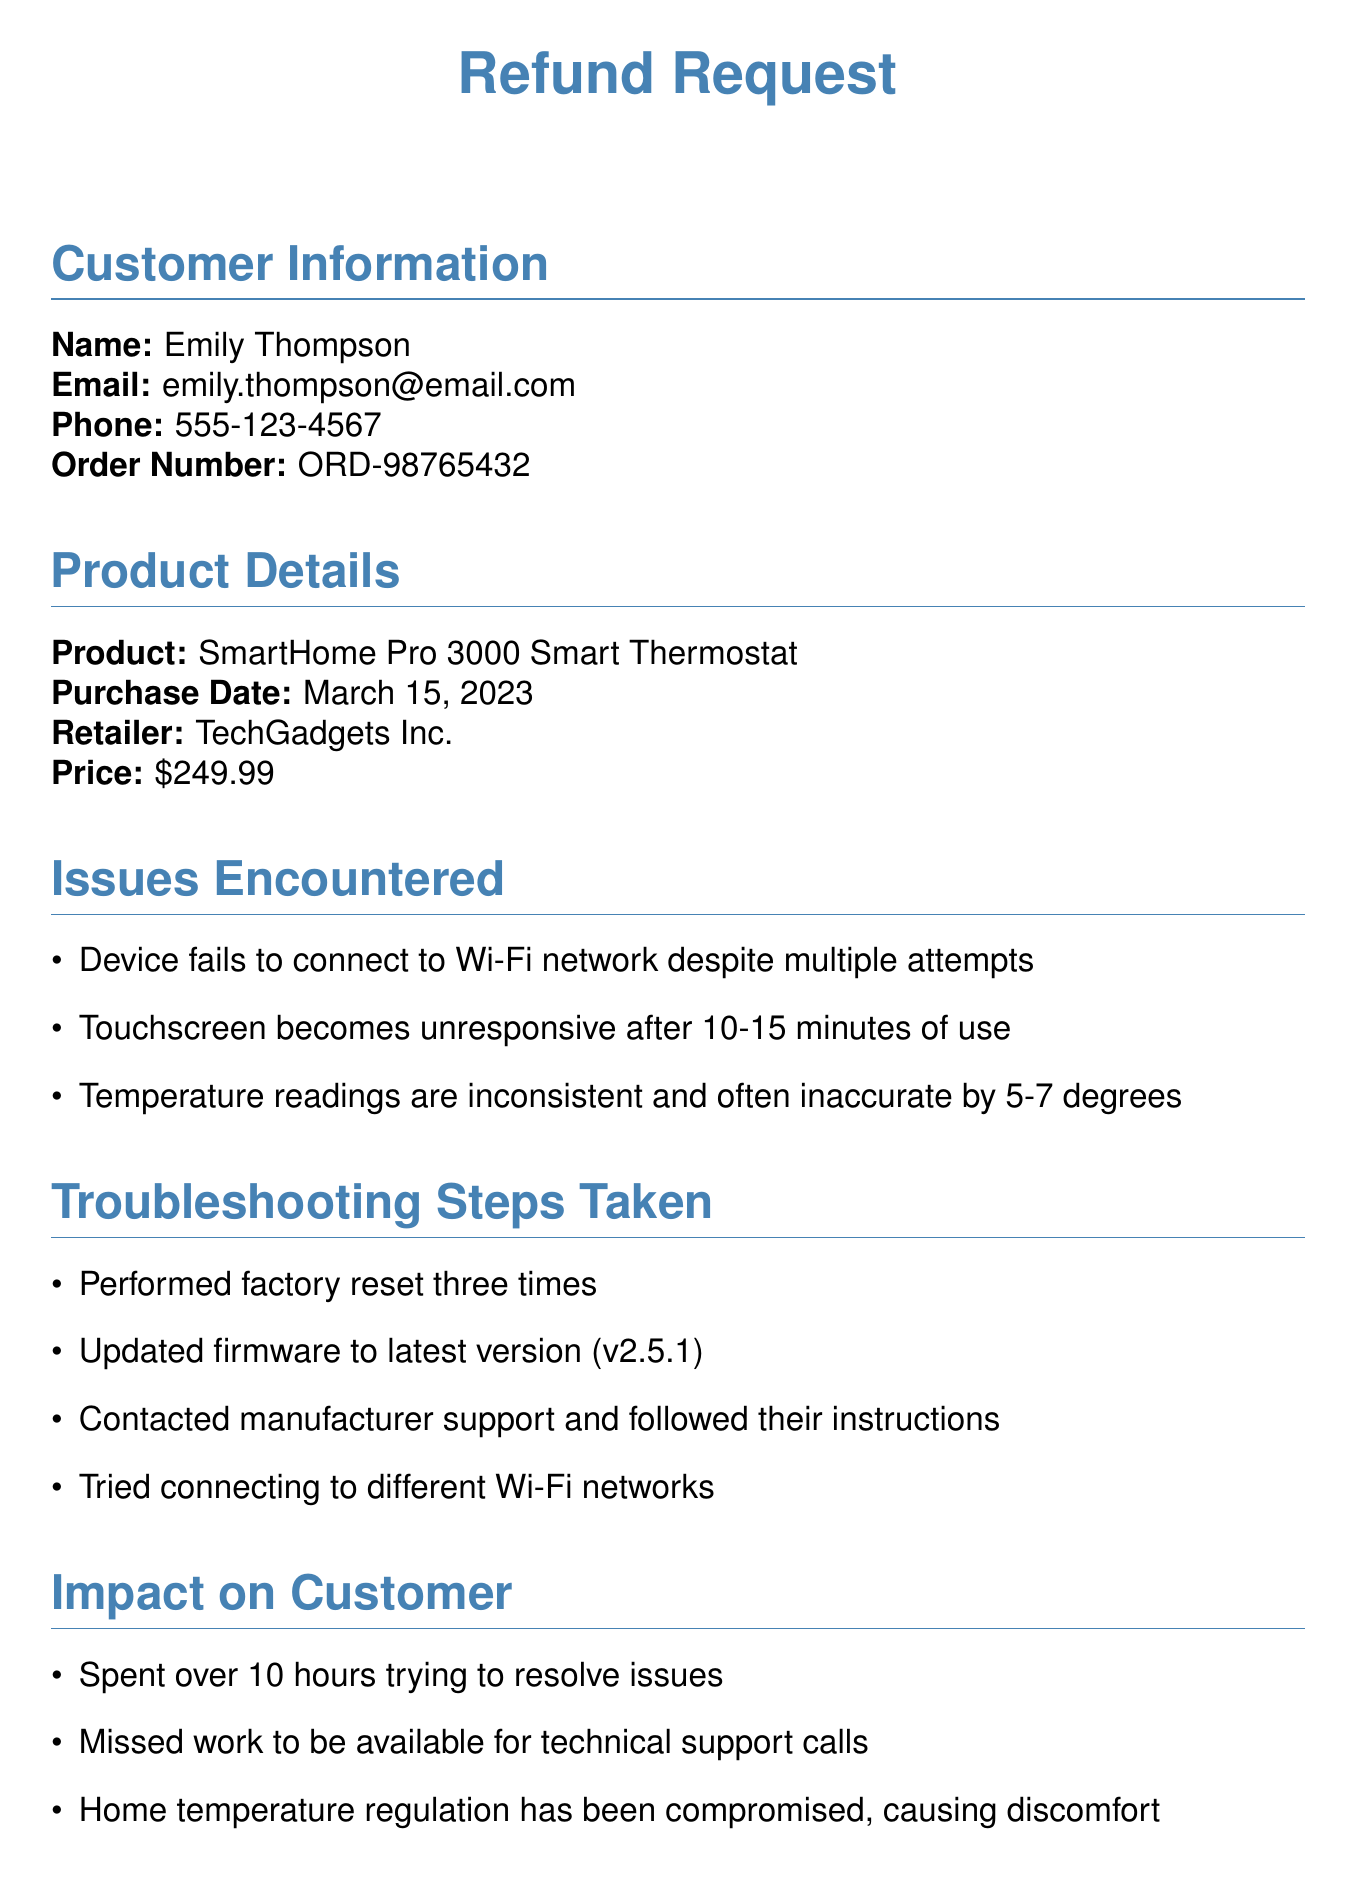What is the name of the customer? The customer's name is specified in the document as "Emily Thompson."
Answer: Emily Thompson What is the purchase date of the product? The document provides the purchase date as "March 15, 2023."
Answer: March 15, 2023 What is the purchase price of the SmartHome Pro 3000? The document lists the purchase price as "$249.99."
Answer: $249.99 What issues did the customer encounter with the device? The document details multiple issues, including Wi-Fi connectivity problems and touchscreen unresponsiveness.
Answer: Device fails to connect to Wi-Fi network despite multiple attempts How many hours did the customer spend trying to resolve the issues? The document states that the customer spent "over 10 hours trying to resolve issues."
Answer: over 10 hours What type of refund is the customer requesting? The document specifies a "Full refund of the purchase price, including any applicable taxes and shipping fees."
Answer: Full refund What troubleshooting step was attempted three times? The document mentions that a factory reset was performed three times.
Answer: factory reset Which retailer sold the product? The retailer is named in the document as "TechGadgets Inc."
Answer: TechGadgets Inc What is the customer's sentiment towards the customer service team? The document expresses the customer's appreciation for the "patience and empathy" shown by the customer service team.
Answer: patience and empathy 